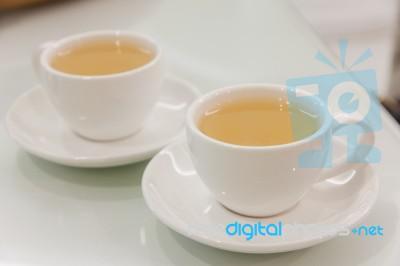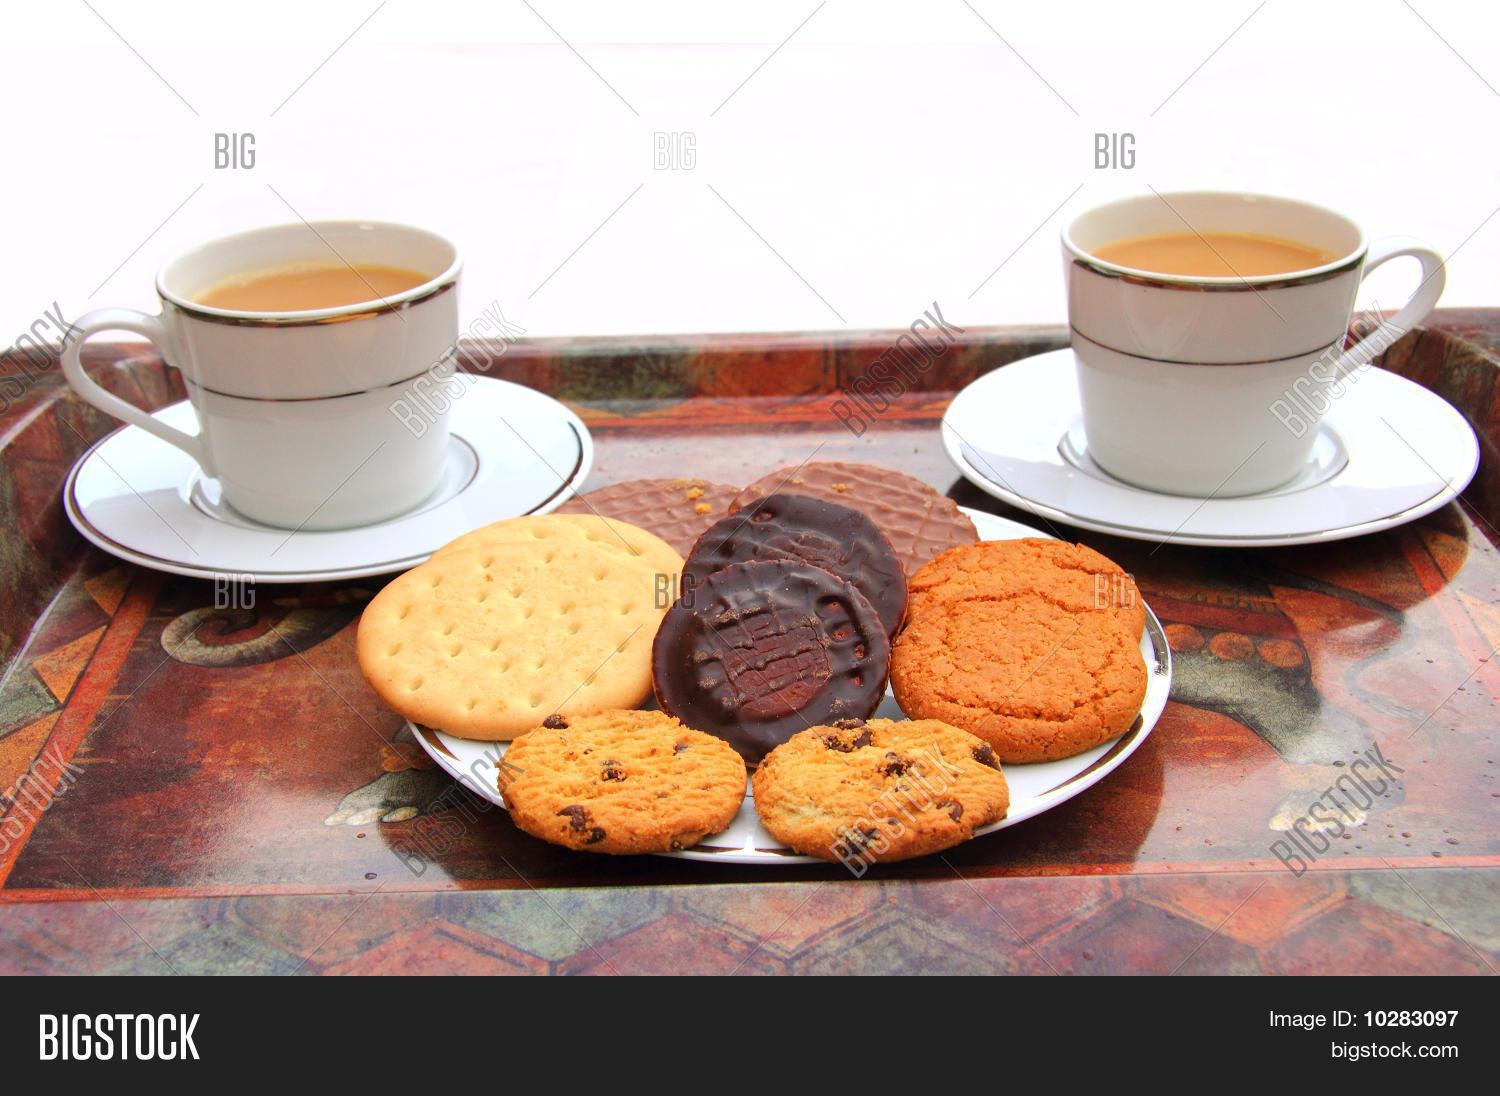The first image is the image on the left, the second image is the image on the right. For the images displayed, is the sentence "An image shows a white pitcher next to at least one filled mug on a saucer." factually correct? Answer yes or no. No. 